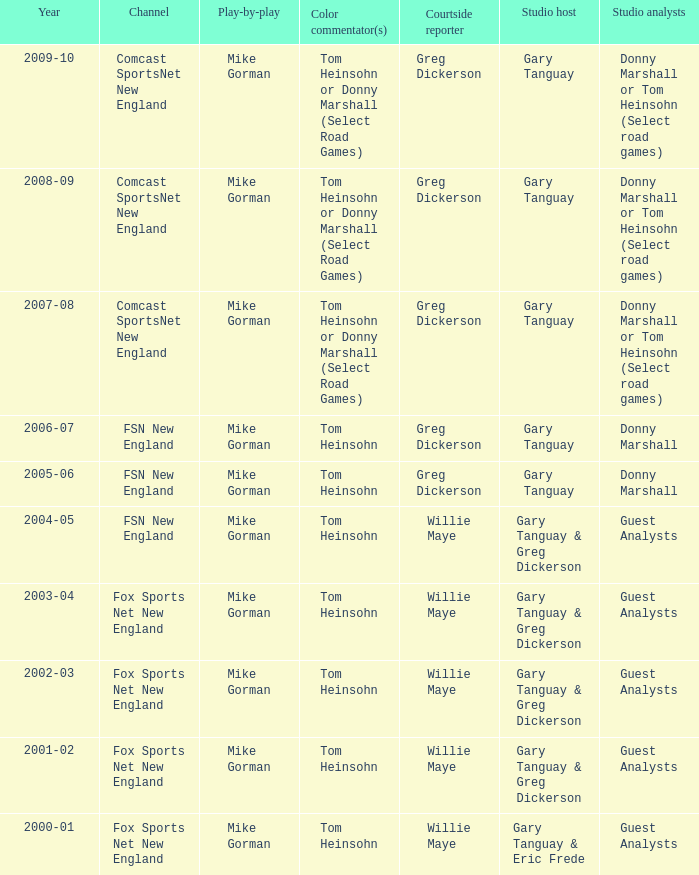WHich Play-by-play has a Studio host of gary tanguay, and a Studio analysts of donny marshall? Mike Gorman, Mike Gorman. 